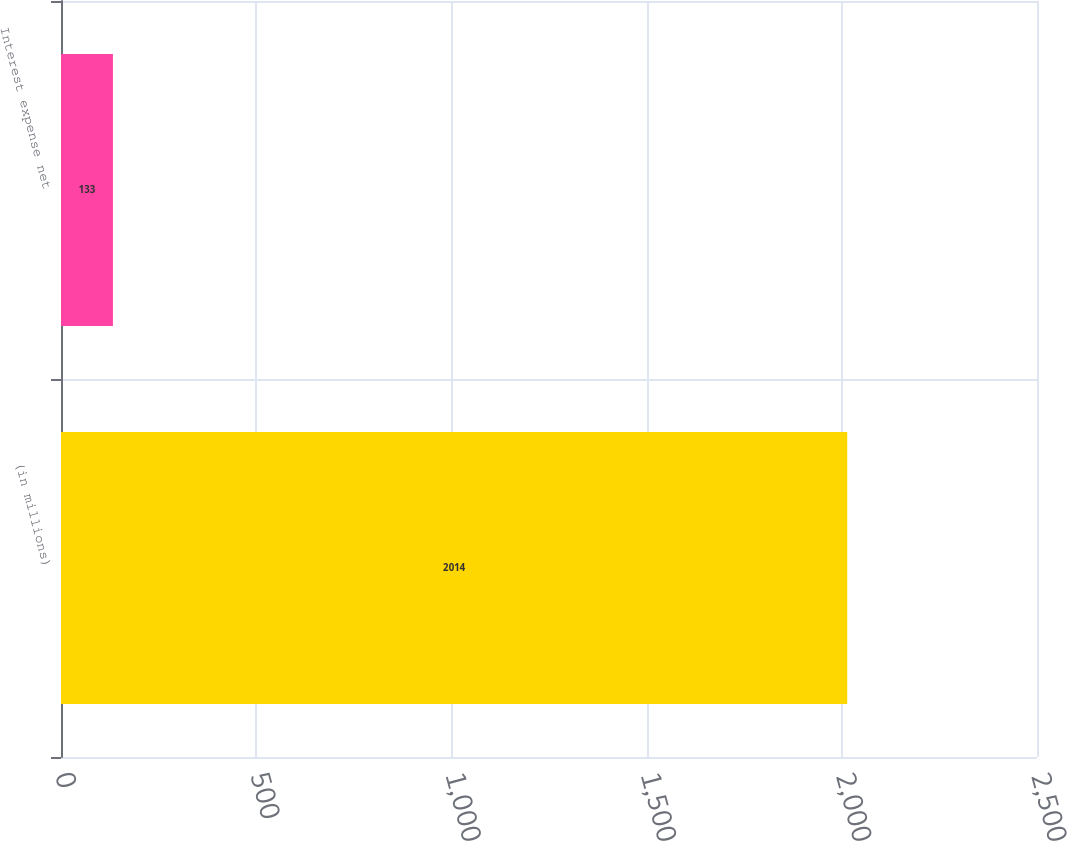Convert chart to OTSL. <chart><loc_0><loc_0><loc_500><loc_500><bar_chart><fcel>(in millions)<fcel>Interest expense net<nl><fcel>2014<fcel>133<nl></chart> 